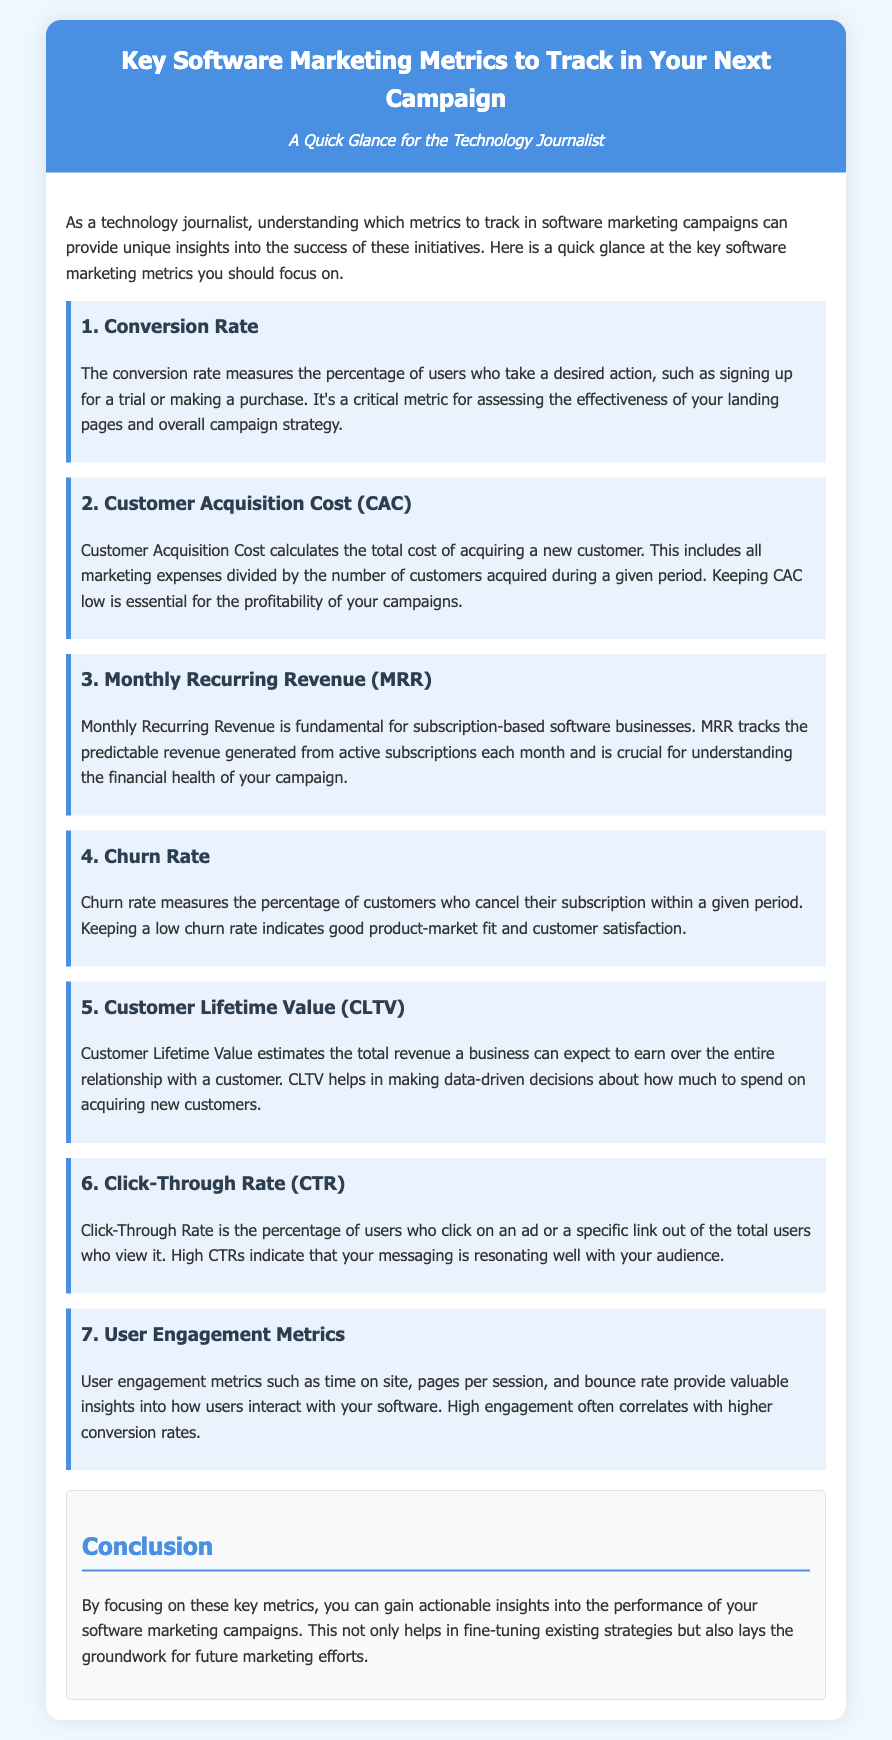What is the first key software marketing metric listed? The document lists "Conversion Rate" as the first metric among the key software marketing metrics to track.
Answer: Conversion Rate What does CAC stand for? The acronym CAC is defined in the document as Customer Acquisition Cost.
Answer: Customer Acquisition Cost What is the significance of Monthly Recurring Revenue? The document indicates that MRR is fundamental for subscription-based software businesses and tracks predictable revenue from subscriptions.
Answer: Predictable revenue What is the maximum word count for the title of the document? The title of the document consists of 13 words.
Answer: 13 Which metric indicates customer satisfaction? Churn Rate measures the percentage of customers who cancel their subscription, which indicates customer satisfaction.
Answer: Churn Rate What does CLTV estimate? The document states that Customer Lifetime Value estimates the total revenue a business can expect to earn from a customer over their entire relationship.
Answer: Total revenue What metric correlates with higher conversion rates? User Engagement Metrics are associated in the document with higher conversion rates.
Answer: User Engagement Metrics How many key metrics are highlighted in the document? The document explicitly lists seven key software marketing metrics to focus on.
Answer: Seven What is the conclusion's main focus? The conclusion emphasizes gaining actionable insights into the performance of software marketing campaigns.
Answer: Actionable insights 